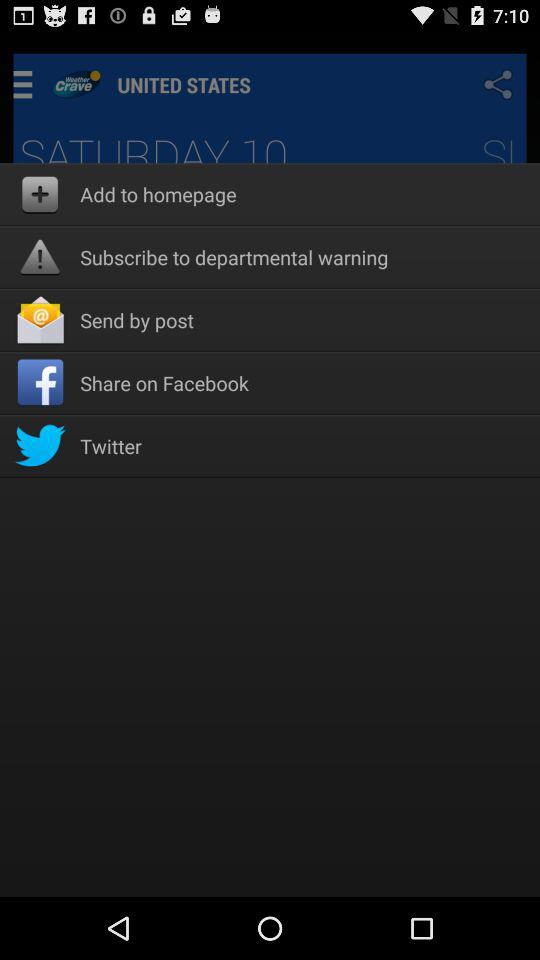What are the sharing options? The sharing option is "Facebook". 